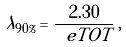<formula> <loc_0><loc_0><loc_500><loc_500>\lambda _ { 9 0 \% } = \frac { 2 . 3 0 } { \ e T O T } \, ,</formula> 